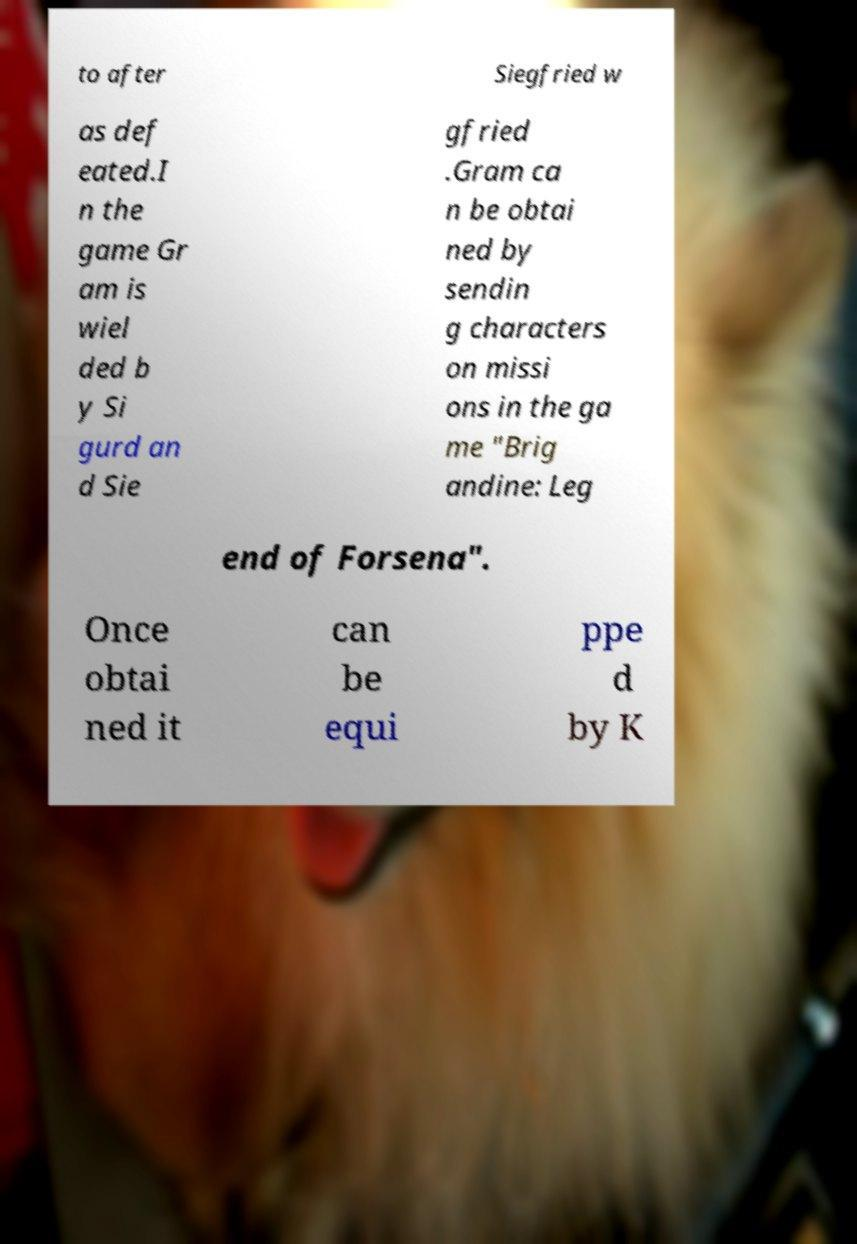What messages or text are displayed in this image? I need them in a readable, typed format. to after Siegfried w as def eated.I n the game Gr am is wiel ded b y Si gurd an d Sie gfried .Gram ca n be obtai ned by sendin g characters on missi ons in the ga me "Brig andine: Leg end of Forsena". Once obtai ned it can be equi ppe d by K 